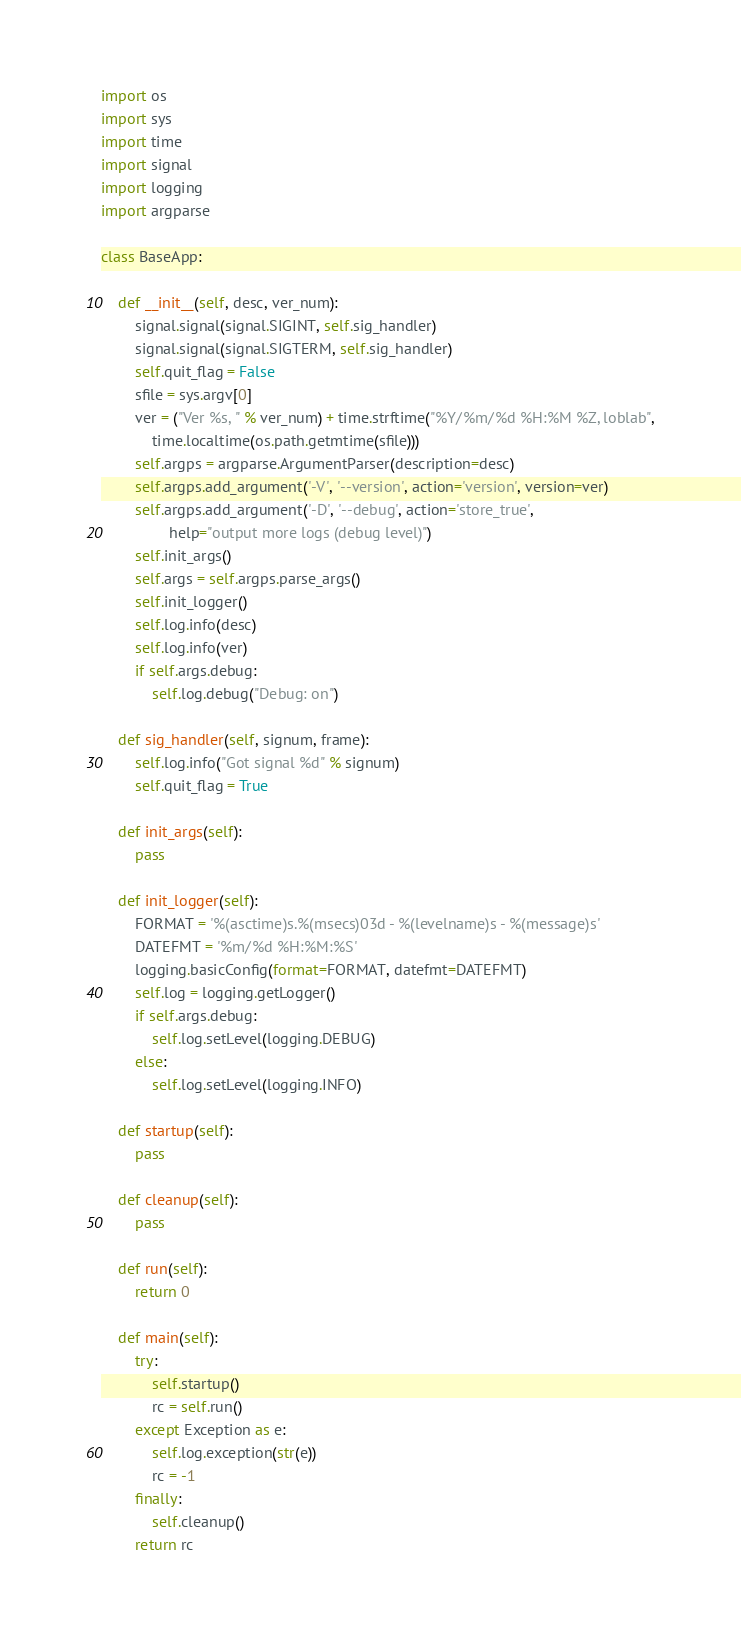<code> <loc_0><loc_0><loc_500><loc_500><_Python_>import os
import sys
import time
import signal
import logging
import argparse

class BaseApp:

    def __init__(self, desc, ver_num):
        signal.signal(signal.SIGINT, self.sig_handler)
        signal.signal(signal.SIGTERM, self.sig_handler)
        self.quit_flag = False
        sfile = sys.argv[0]
        ver = ("Ver %s, " % ver_num) + time.strftime("%Y/%m/%d %H:%M %Z, loblab",
            time.localtime(os.path.getmtime(sfile)))
        self.argps = argparse.ArgumentParser(description=desc)
        self.argps.add_argument('-V', '--version', action='version', version=ver)
        self.argps.add_argument('-D', '--debug', action='store_true',
                help="output more logs (debug level)")
        self.init_args()
        self.args = self.argps.parse_args()
        self.init_logger()
        self.log.info(desc)
        self.log.info(ver)
        if self.args.debug:
            self.log.debug("Debug: on")

    def sig_handler(self, signum, frame):
        self.log.info("Got signal %d" % signum)
        self.quit_flag = True

    def init_args(self):
        pass

    def init_logger(self):
        FORMAT = '%(asctime)s.%(msecs)03d - %(levelname)s - %(message)s'
        DATEFMT = '%m/%d %H:%M:%S'
        logging.basicConfig(format=FORMAT, datefmt=DATEFMT)
        self.log = logging.getLogger()
        if self.args.debug:
            self.log.setLevel(logging.DEBUG)
        else:
            self.log.setLevel(logging.INFO)

    def startup(self):
        pass

    def cleanup(self):
        pass

    def run(self):
        return 0

    def main(self):
        try:
            self.startup()
            rc = self.run()
        except Exception as e:
            self.log.exception(str(e))
            rc = -1
        finally:
            self.cleanup()
        return rc

</code> 